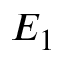Convert formula to latex. <formula><loc_0><loc_0><loc_500><loc_500>E _ { 1 }</formula> 